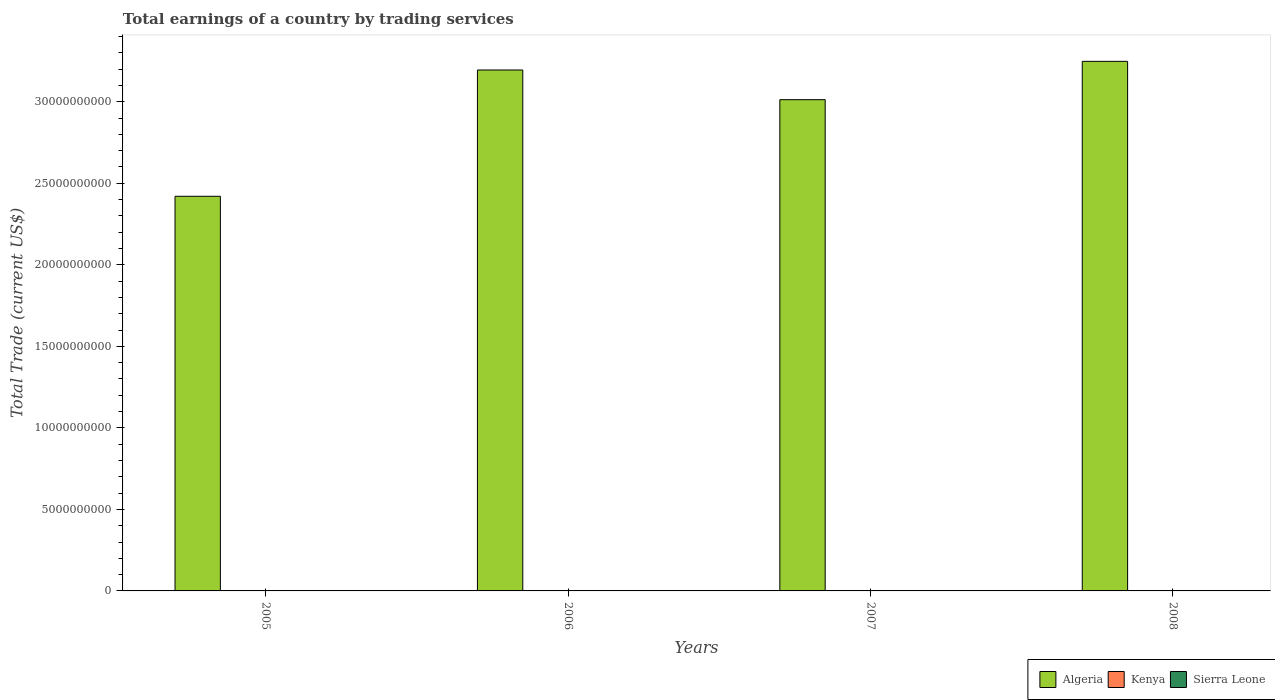Are the number of bars per tick equal to the number of legend labels?
Ensure brevity in your answer.  No. How many bars are there on the 2nd tick from the left?
Ensure brevity in your answer.  1. In how many cases, is the number of bars for a given year not equal to the number of legend labels?
Provide a short and direct response. 4. What is the total earnings in Algeria in 2007?
Make the answer very short. 3.01e+1. Across all years, what is the maximum total earnings in Algeria?
Your answer should be compact. 3.25e+1. In which year was the total earnings in Algeria maximum?
Make the answer very short. 2008. What is the difference between the total earnings in Algeria in 2006 and that in 2008?
Offer a terse response. -5.29e+08. What is the average total earnings in Algeria per year?
Make the answer very short. 2.97e+1. What is the ratio of the total earnings in Algeria in 2006 to that in 2008?
Your answer should be very brief. 0.98. What is the difference between the highest and the second highest total earnings in Algeria?
Your response must be concise. 5.29e+08. What is the difference between the highest and the lowest total earnings in Algeria?
Provide a succinct answer. 8.28e+09. Is it the case that in every year, the sum of the total earnings in Sierra Leone and total earnings in Algeria is greater than the total earnings in Kenya?
Offer a very short reply. Yes. How many bars are there?
Make the answer very short. 4. What is the difference between two consecutive major ticks on the Y-axis?
Your answer should be very brief. 5.00e+09. Are the values on the major ticks of Y-axis written in scientific E-notation?
Ensure brevity in your answer.  No. Does the graph contain grids?
Your answer should be compact. No. Where does the legend appear in the graph?
Make the answer very short. Bottom right. How many legend labels are there?
Give a very brief answer. 3. What is the title of the graph?
Make the answer very short. Total earnings of a country by trading services. What is the label or title of the Y-axis?
Your answer should be very brief. Total Trade (current US$). What is the Total Trade (current US$) of Algeria in 2005?
Offer a very short reply. 2.42e+1. What is the Total Trade (current US$) of Kenya in 2005?
Provide a short and direct response. 0. What is the Total Trade (current US$) in Sierra Leone in 2005?
Your answer should be compact. 0. What is the Total Trade (current US$) of Algeria in 2006?
Your answer should be compact. 3.19e+1. What is the Total Trade (current US$) of Kenya in 2006?
Give a very brief answer. 0. What is the Total Trade (current US$) in Algeria in 2007?
Provide a short and direct response. 3.01e+1. What is the Total Trade (current US$) in Algeria in 2008?
Offer a very short reply. 3.25e+1. What is the Total Trade (current US$) of Sierra Leone in 2008?
Provide a short and direct response. 0. Across all years, what is the maximum Total Trade (current US$) in Algeria?
Give a very brief answer. 3.25e+1. Across all years, what is the minimum Total Trade (current US$) in Algeria?
Provide a succinct answer. 2.42e+1. What is the total Total Trade (current US$) of Algeria in the graph?
Provide a short and direct response. 1.19e+11. What is the total Total Trade (current US$) in Sierra Leone in the graph?
Offer a very short reply. 0. What is the difference between the Total Trade (current US$) in Algeria in 2005 and that in 2006?
Ensure brevity in your answer.  -7.75e+09. What is the difference between the Total Trade (current US$) of Algeria in 2005 and that in 2007?
Your answer should be very brief. -5.92e+09. What is the difference between the Total Trade (current US$) of Algeria in 2005 and that in 2008?
Give a very brief answer. -8.28e+09. What is the difference between the Total Trade (current US$) in Algeria in 2006 and that in 2007?
Provide a short and direct response. 1.82e+09. What is the difference between the Total Trade (current US$) of Algeria in 2006 and that in 2008?
Give a very brief answer. -5.29e+08. What is the difference between the Total Trade (current US$) in Algeria in 2007 and that in 2008?
Your answer should be compact. -2.35e+09. What is the average Total Trade (current US$) in Algeria per year?
Your response must be concise. 2.97e+1. What is the average Total Trade (current US$) of Kenya per year?
Offer a very short reply. 0. What is the ratio of the Total Trade (current US$) of Algeria in 2005 to that in 2006?
Make the answer very short. 0.76. What is the ratio of the Total Trade (current US$) of Algeria in 2005 to that in 2007?
Your response must be concise. 0.8. What is the ratio of the Total Trade (current US$) in Algeria in 2005 to that in 2008?
Ensure brevity in your answer.  0.75. What is the ratio of the Total Trade (current US$) of Algeria in 2006 to that in 2007?
Ensure brevity in your answer.  1.06. What is the ratio of the Total Trade (current US$) in Algeria in 2006 to that in 2008?
Ensure brevity in your answer.  0.98. What is the ratio of the Total Trade (current US$) of Algeria in 2007 to that in 2008?
Keep it short and to the point. 0.93. What is the difference between the highest and the second highest Total Trade (current US$) in Algeria?
Your answer should be compact. 5.29e+08. What is the difference between the highest and the lowest Total Trade (current US$) of Algeria?
Offer a very short reply. 8.28e+09. 